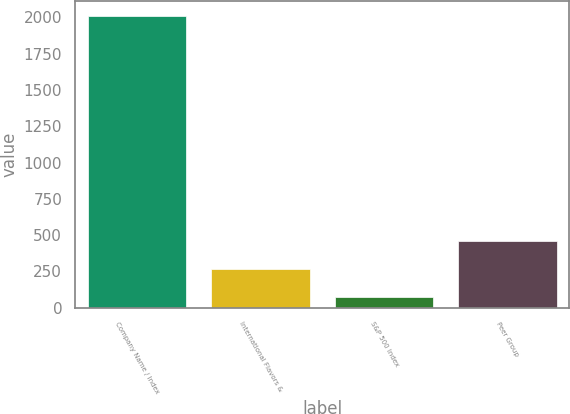Convert chart. <chart><loc_0><loc_0><loc_500><loc_500><bar_chart><fcel>Company Name / Index<fcel>International Flavors &<fcel>S&P 500 Index<fcel>Peer Group<nl><fcel>2008<fcel>270.06<fcel>76.96<fcel>463.16<nl></chart> 